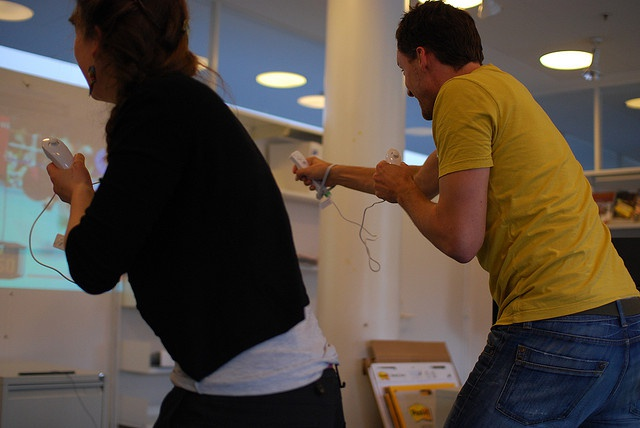Describe the objects in this image and their specific colors. I can see people in gray, black, and maroon tones, people in gray, black, olive, and maroon tones, book in gray, maroon, and olive tones, remote in gray and maroon tones, and remote in gray and black tones in this image. 